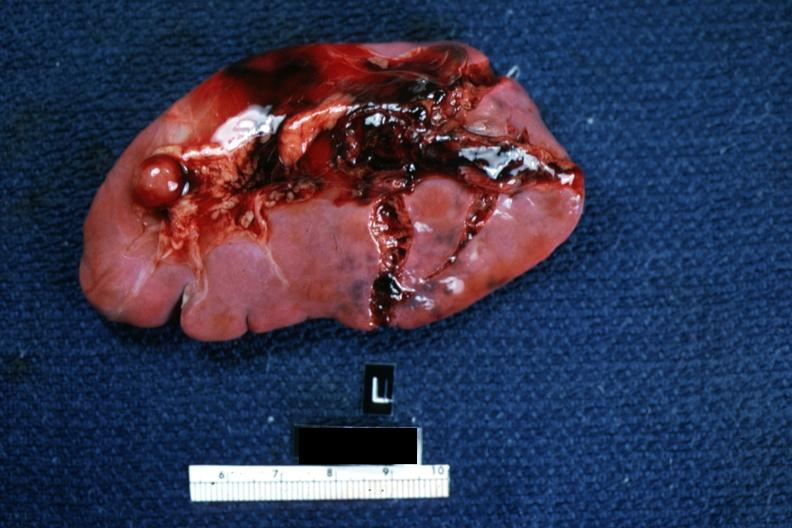does this image show typical lacerations?
Answer the question using a single word or phrase. Yes 